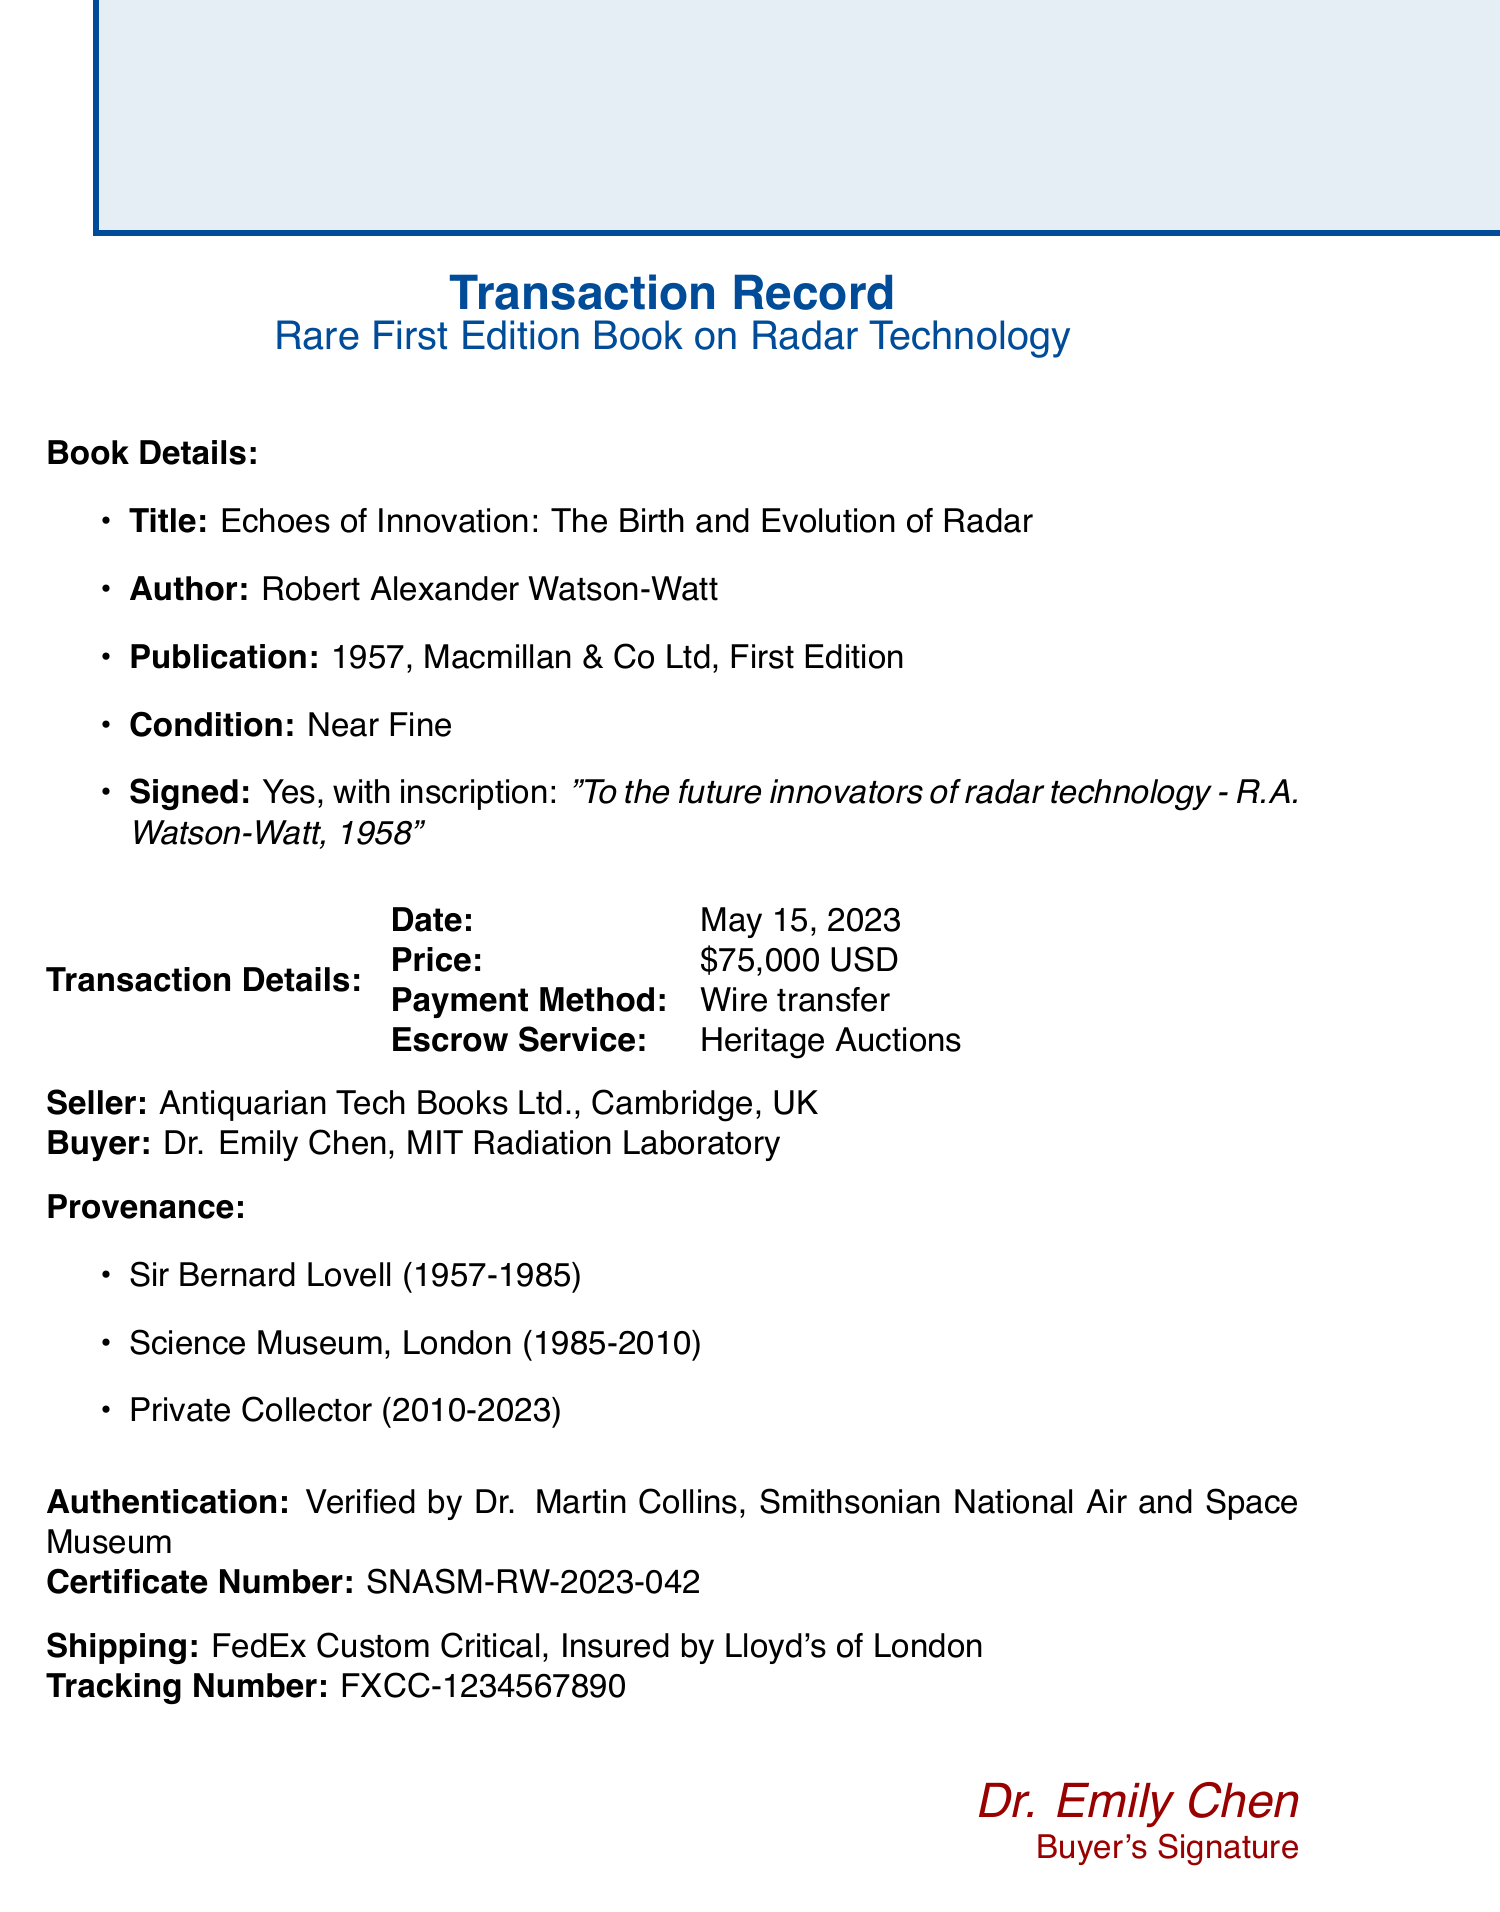what is the title of the book? The title of the book is the main subject of inquiry in this transaction document.
Answer: Echoes of Innovation: The Birth and Evolution of Radar who is the author of the book? The author is an essential detail that identifies who wrote the book.
Answer: Robert Alexander Watson-Watt what is the publication year of the book? The publication year reflects when the book was printed, which is relevant for its historical context.
Answer: 1957 how much did the book sell for? The selling price is a crucial detail in the transaction, indicating the book's financial value.
Answer: 75000 who was the first owner of the book? The first owner provides provenance information, which is significant for authenticity and historical tracing.
Answer: Sir Bernard Lovell what is the payment method used in the transaction? Understanding the payment method gives insights into the transaction's nature and reliability.
Answer: Wire transfer who authenticated the book's signature? The expert who verified the authenticity is important for establishing trust in the transaction.
Answer: Dr. Martin Collins what type of shipping was used for the book? The shipping method indicates how the book was transported, affecting safety and delivery considerations.
Answer: FedEx Custom Critical what is included in the additional items provided with the book? The additional items enhance the value and presentation of the book, making it more desirable to collectors.
Answer: Custom-made clamshell box by Gaylord Archival 